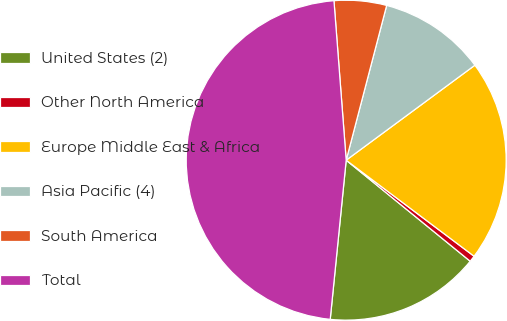Convert chart to OTSL. <chart><loc_0><loc_0><loc_500><loc_500><pie_chart><fcel>United States (2)<fcel>Other North America<fcel>Europe Middle East & Africa<fcel>Asia Pacific (4)<fcel>South America<fcel>Total<nl><fcel>15.71%<fcel>0.63%<fcel>20.37%<fcel>10.81%<fcel>5.29%<fcel>47.19%<nl></chart> 